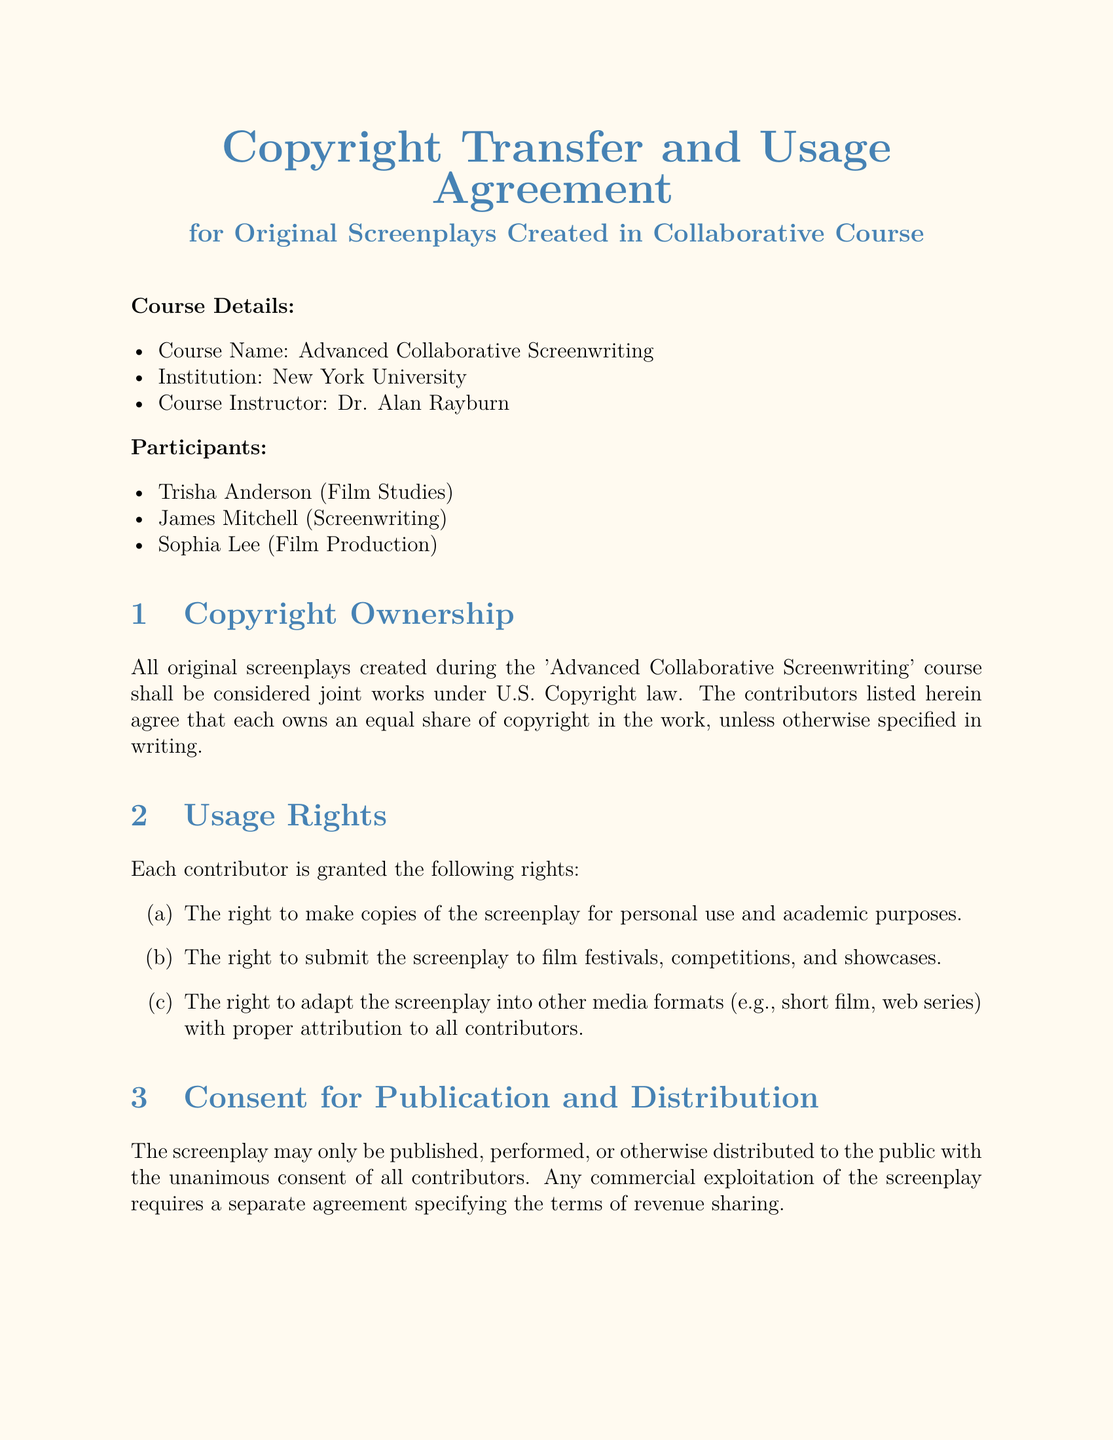What is the course name? The course name is listed at the beginning of the document in the course details section.
Answer: Advanced Collaborative Screenwriting Who is the course instructor? The instructor's name is provided in the course details section along with the institution.
Answer: Dr. Alan Rayburn How many participants are listed in the agreement? The number of participants can be counted in the participants section of the document.
Answer: 3 What rights do contributors have for personal use? The document specifies the rights granted to contributors in the usage rights section, focusing on personal use.
Answer: Make copies of the screenplay When was the document signed? The date is provided next to each participant's signature at the end of the document.
Answer: 2023-07-15 What must happen for the screenplay to be published? This requirement is stated in the consent for publication and distribution section.
Answer: Unanimous consent of all contributors Which contributor is associated with Film Production? The participants section lists the contributors and their associated fields.
Answer: Sophia Lee What type of rights do contributors have regarding adaptation? The usage rights section defines the specific rights pertaining to adaptation.
Answer: Adapt the screenplay into other media formats What is required for commercial exploitation of the screenplay? This information is found in the consent for publication and distribution section regarding commercial use.
Answer: A separate agreement specifying the terms of revenue sharing 